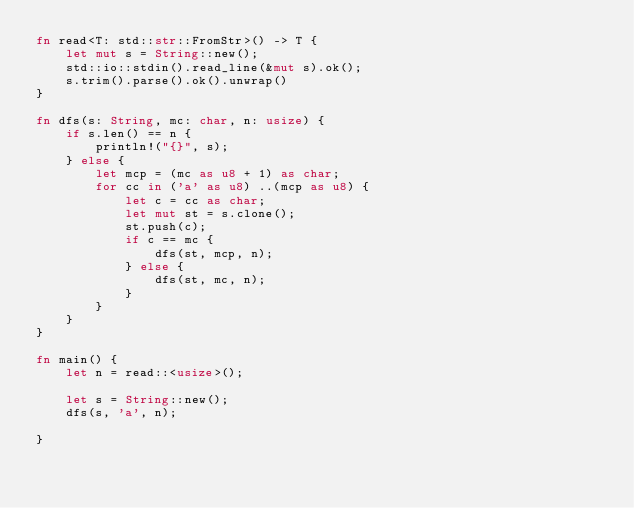Convert code to text. <code><loc_0><loc_0><loc_500><loc_500><_Rust_>fn read<T: std::str::FromStr>() -> T {
    let mut s = String::new();
    std::io::stdin().read_line(&mut s).ok();
    s.trim().parse().ok().unwrap()
}

fn dfs(s: String, mc: char, n: usize) {
    if s.len() == n {
        println!("{}", s);
    } else {
        let mcp = (mc as u8 + 1) as char;
        for cc in ('a' as u8) ..(mcp as u8) {
            let c = cc as char;
            let mut st = s.clone();
            st.push(c);
            if c == mc {
                dfs(st, mcp, n);
            } else {
                dfs(st, mc, n);
            }
        }
    }
}

fn main() {
    let n = read::<usize>();

    let s = String::new();
    dfs(s, 'a', n);

}</code> 